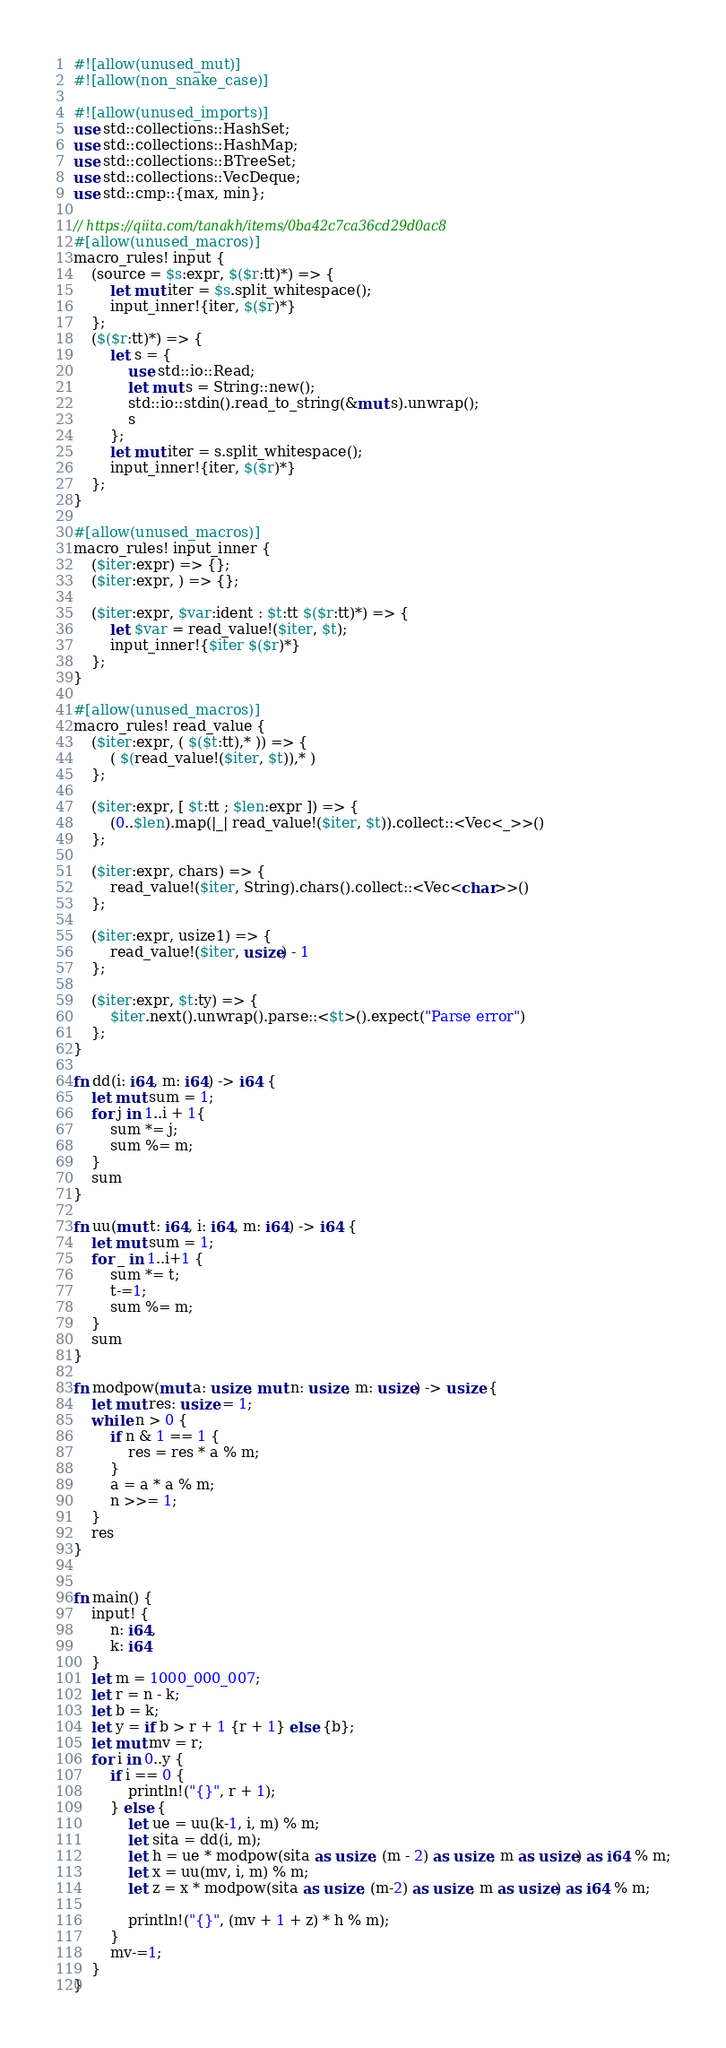Convert code to text. <code><loc_0><loc_0><loc_500><loc_500><_Rust_>#![allow(unused_mut)]
#![allow(non_snake_case)]

#![allow(unused_imports)]
use std::collections::HashSet;
use std::collections::HashMap;
use std::collections::BTreeSet;
use std::collections::VecDeque;
use std::cmp::{max, min};

// https://qiita.com/tanakh/items/0ba42c7ca36cd29d0ac8
#[allow(unused_macros)]
macro_rules! input {
    (source = $s:expr, $($r:tt)*) => {
        let mut iter = $s.split_whitespace();
        input_inner!{iter, $($r)*}
    };
    ($($r:tt)*) => {
        let s = {
            use std::io::Read;
            let mut s = String::new();
            std::io::stdin().read_to_string(&mut s).unwrap();
            s
        };
        let mut iter = s.split_whitespace();
        input_inner!{iter, $($r)*}
    };
}

#[allow(unused_macros)]
macro_rules! input_inner {
    ($iter:expr) => {};
    ($iter:expr, ) => {};

    ($iter:expr, $var:ident : $t:tt $($r:tt)*) => {
        let $var = read_value!($iter, $t);
        input_inner!{$iter $($r)*}
    };
}

#[allow(unused_macros)]
macro_rules! read_value {
    ($iter:expr, ( $($t:tt),* )) => {
        ( $(read_value!($iter, $t)),* )
    };

    ($iter:expr, [ $t:tt ; $len:expr ]) => {
        (0..$len).map(|_| read_value!($iter, $t)).collect::<Vec<_>>()
    };

    ($iter:expr, chars) => {
        read_value!($iter, String).chars().collect::<Vec<char>>()
    };

    ($iter:expr, usize1) => {
        read_value!($iter, usize) - 1
    };

    ($iter:expr, $t:ty) => {
        $iter.next().unwrap().parse::<$t>().expect("Parse error")
    };
}

fn dd(i: i64, m: i64) -> i64 {
    let mut sum = 1;
    for j in 1..i + 1{
        sum *= j;
        sum %= m;
    }
    sum
}

fn uu(mut t: i64, i: i64, m: i64) -> i64 {
    let mut sum = 1;
    for _ in 1..i+1 {
        sum *= t;
        t-=1;
        sum %= m;
    }
    sum
}

fn modpow(mut a: usize, mut n: usize, m: usize) -> usize {
    let mut res: usize = 1;
    while n > 0 {
        if n & 1 == 1 {
            res = res * a % m;
        }
        a = a * a % m;
        n >>= 1;
    }
    res
}


fn main() {
    input! {
        n: i64,
        k: i64
    }
    let m = 1000_000_007;
    let r = n - k;
    let b = k;
    let y = if b > r + 1 {r + 1} else {b};
    let mut mv = r;
    for i in 0..y {
        if i == 0 {
            println!("{}", r + 1);
        } else {
            let ue = uu(k-1, i, m) % m;
            let sita = dd(i, m);
            let h = ue * modpow(sita as usize, (m - 2) as usize, m as usize) as i64 % m;
            let x = uu(mv, i, m) % m;
            let z = x * modpow(sita as usize, (m-2) as usize, m as usize) as i64 % m;

            println!("{}", (mv + 1 + z) * h % m);
        }
        mv-=1;
    }
}</code> 